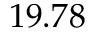<formula> <loc_0><loc_0><loc_500><loc_500>1 9 . 7 8</formula> 